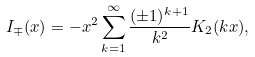<formula> <loc_0><loc_0><loc_500><loc_500>I _ { \mp } ( x ) = - x ^ { 2 } \sum _ { k = 1 } ^ { \infty } \frac { ( \pm 1 ) ^ { k + 1 } } { k ^ { 2 } } K _ { 2 } ( k x ) ,</formula> 